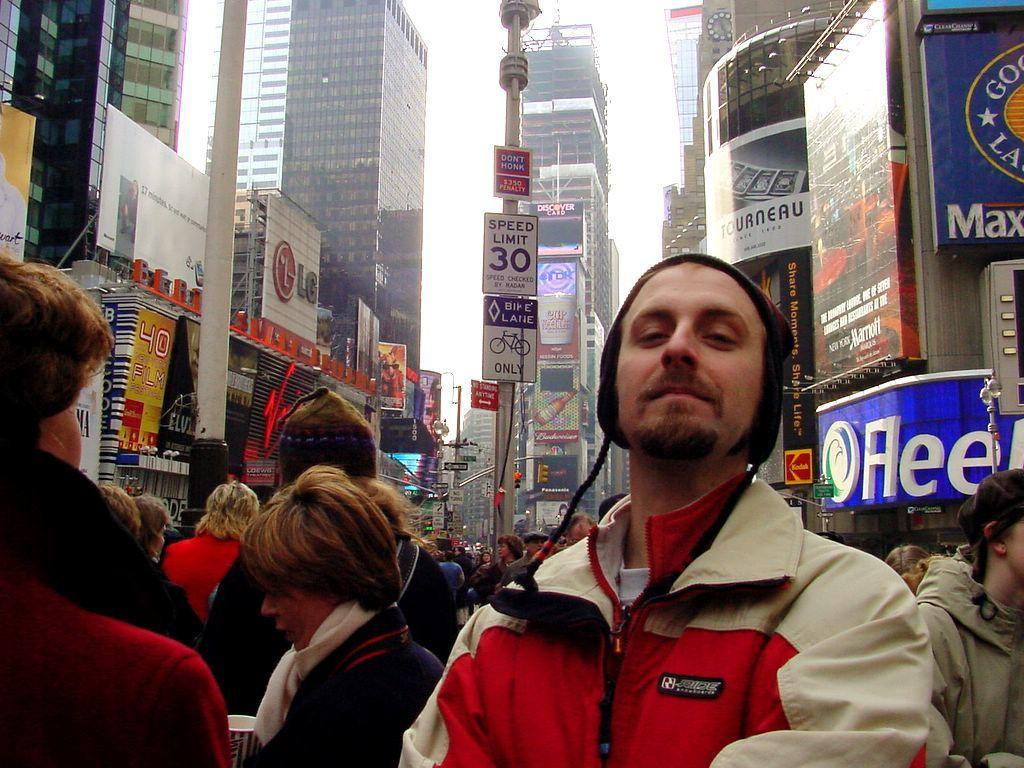<image>
Summarize the visual content of the image. A man in a had stands on a street; the word Flee is visible on a sign in the background. 